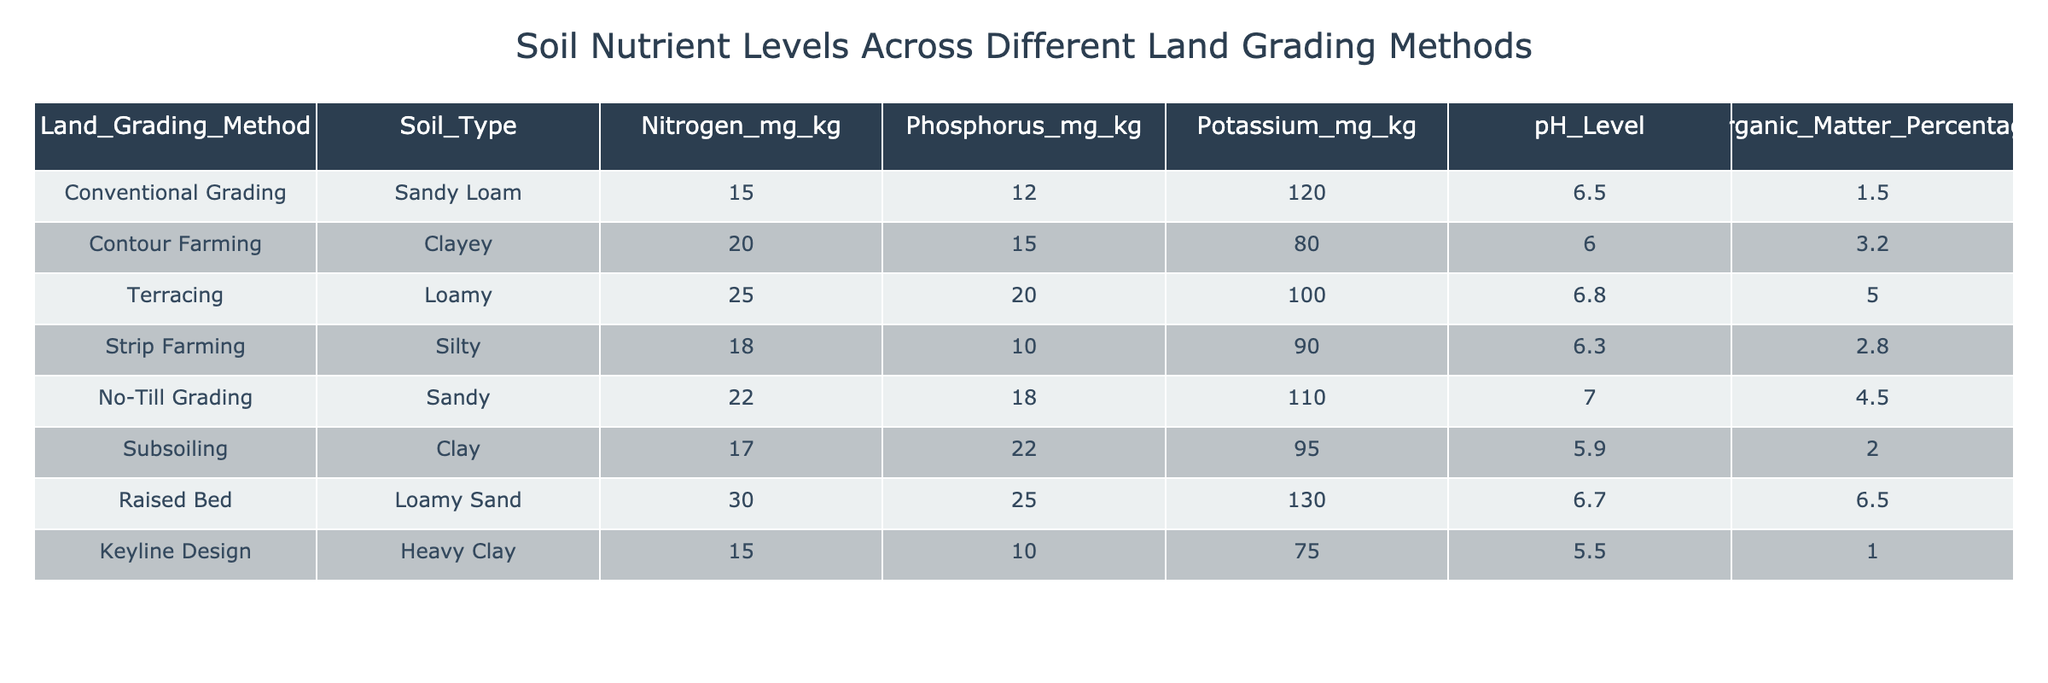What are the nitrogen levels in the soil for the Raised Bed method? The table shows that the nitrogen level in the soil for the Raised Bed method is listed under the column for Nitrogen_mg_kg. By checking this row specifically, I can see that the value is 30.
Answer: 30 Which land grading method has the lowest phosphorus level? To find the lowest phosphorus level, I compare the values under the Phosphorus_mg_kg column for each method. The lowest value is 10 mg/kg, which corresponds to the Keyline Design method.
Answer: Keyline Design What is the average potassium level for all land grading methods? To calculate the average potassium level, I first add together all the potassium values: 120 + 80 + 100 + 90 + 110 + 95 + 130 + 75 = 800. There are 8 land grading methods, so I divide the total (800) by 8, resulting in an average of 100.
Answer: 100 Is the pH level of the soil higher in Contour Farming than in Strip Farming? By comparing the pH levels from the table, I find that Contour Farming has a pH of 6.0, while Strip Farming has a pH of 6.3. Since 6.3 is greater than 6.0, the statement is false.
Answer: No Which land grading method has the highest percentage of organic matter? I check the Organic_Matter_Percentage column and find the values. The Raised Bed method has the highest value of 6.5%, which is greater than all other methods listed.
Answer: Raised Bed What is the difference in nitrogen levels between the No-Till Grading and Subsoiling methods? The nitrogen level for No-Till Grading is 22 mg/kg and for Subsoiling, it is 17 mg/kg. The difference is calculated by subtracting the two values: 22 - 17 = 5.
Answer: 5 Which soil type corresponds to the highest potassium level? Checking the Potassium_mg_kg column, the highest level is 130 mg/kg, which corresponds to the Raised Bed soil type. I can confirm this by looking at the relevant row.
Answer: Loamy Sand Is the organic matter percentage for Contour Farming greater than or equal to 3%? The table indicates that the organic matter percentage for Contour Farming is 3.2%. Since 3.2% is greater than 3%, the answer is true.
Answer: Yes 